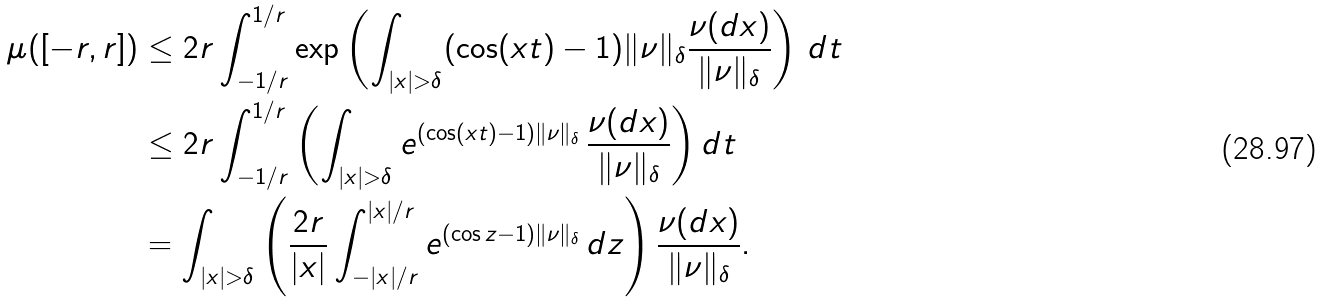Convert formula to latex. <formula><loc_0><loc_0><loc_500><loc_500>\mu ( [ - r , r ] ) & \leq 2 r \int _ { - 1 / r } ^ { 1 / r } \exp \left ( \int _ { | x | > \delta } ( \cos ( x t ) - 1 ) \| \nu \| _ { \delta } \frac { \nu ( d x ) } { \| \nu \| _ { \delta } } \right ) \, d t \\ & \leq 2 r \int _ { - 1 / r } ^ { 1 / r } \left ( \int _ { | x | > \delta } e ^ { ( \cos ( x t ) - 1 ) \| \nu \| _ { \delta } } \, \frac { \nu ( d x ) } { \| \nu \| _ { \delta } } \right ) d t \\ & = \int _ { | x | > \delta } \left ( \frac { 2 r } { | x | } \int _ { - | x | / r } ^ { | x | / r } e ^ { ( \cos z - 1 ) \| \nu \| _ { \delta } } \, d z \right ) \frac { \nu ( d x ) } { \| \nu \| _ { \delta } } .</formula> 